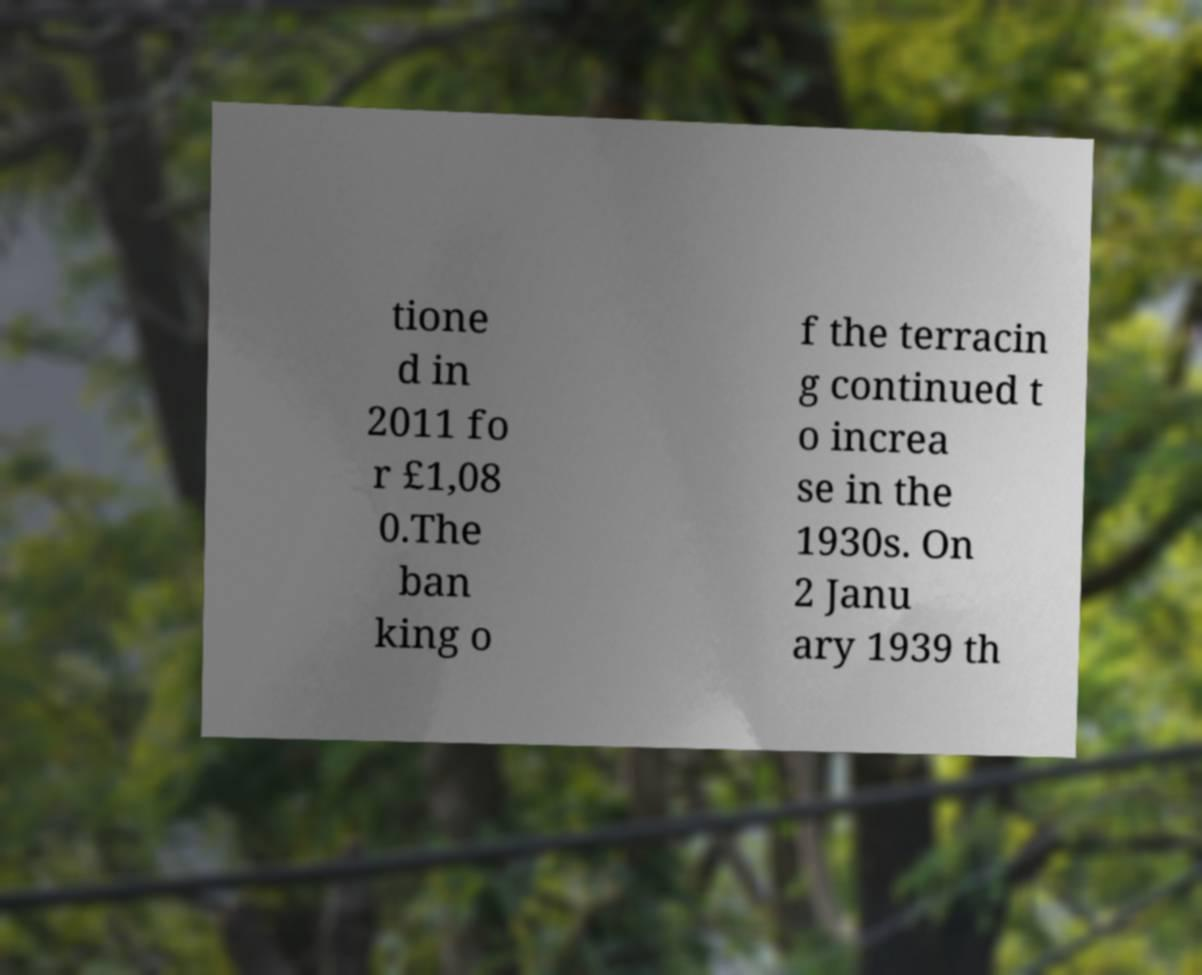Please identify and transcribe the text found in this image. tione d in 2011 fo r £1,08 0.The ban king o f the terracin g continued t o increa se in the 1930s. On 2 Janu ary 1939 th 